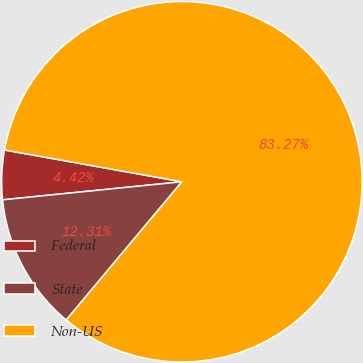Convert chart to OTSL. <chart><loc_0><loc_0><loc_500><loc_500><pie_chart><fcel>Federal<fcel>State<fcel>Non-US<nl><fcel>4.42%<fcel>12.31%<fcel>83.27%<nl></chart> 